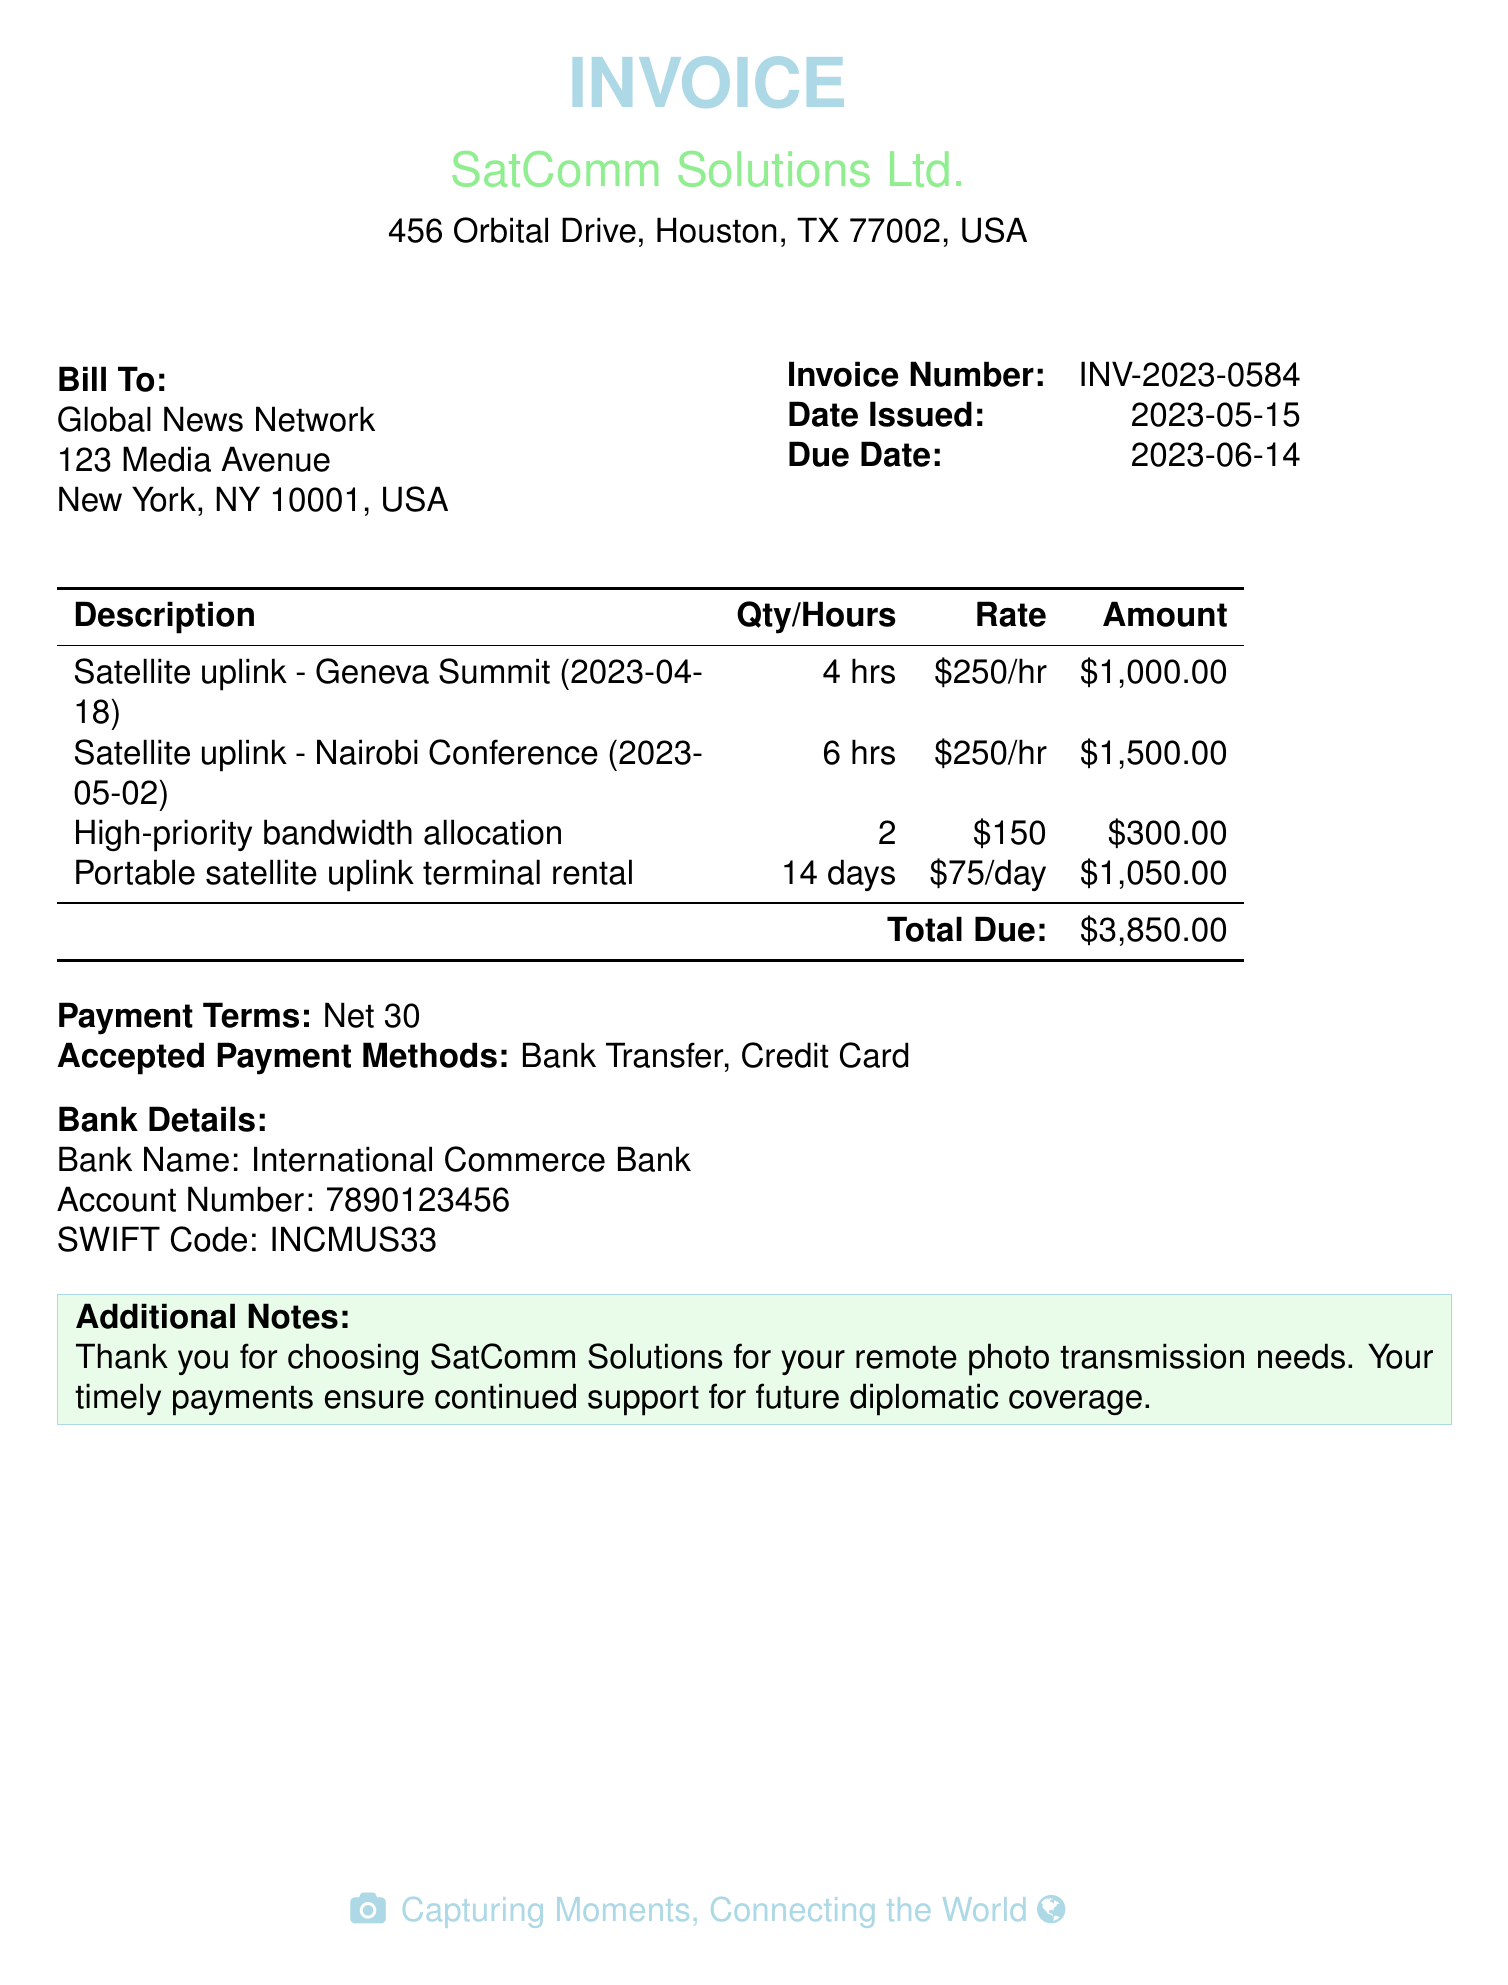what is the invoice number? The invoice number is specifically listed in the document to identify the billing, which is INV-2023-0584.
Answer: INV-2023-0584 what is the total due amount? The total due amount is the final sum calculated for all services listed in the invoice, which is $3,850.00.
Answer: $3,850.00 when was the invoice issued? The date issued is explicitly mentioned in the document, which is May 15, 2023.
Answer: 2023-05-15 what service was provided for the Geneva Summit? The invoice describes the service provided for the Geneva Summit as "Satellite uplink."
Answer: Satellite uplink how many hours were billed for the Nairobi Conference? The document specifies the quantity of hours for the Nairobi Conference, which is 6 hours.
Answer: 6 hrs what is the due date for the payment? The due date is clearly stated in the invoice, which is June 14, 2023.
Answer: 2023-06-14 which company issued the invoice? The company that issued the invoice is named at the top of the document, which is SatComm Solutions Ltd.
Answer: SatComm Solutions Ltd what is the daily rental rate for the portable satellite uplink terminal? The daily rental rate is mentioned in the invoice, which is $75 per day.
Answer: $75/day what payment terms are specified in the document? The payment terms are outlined and specified as "Net 30."
Answer: Net 30 